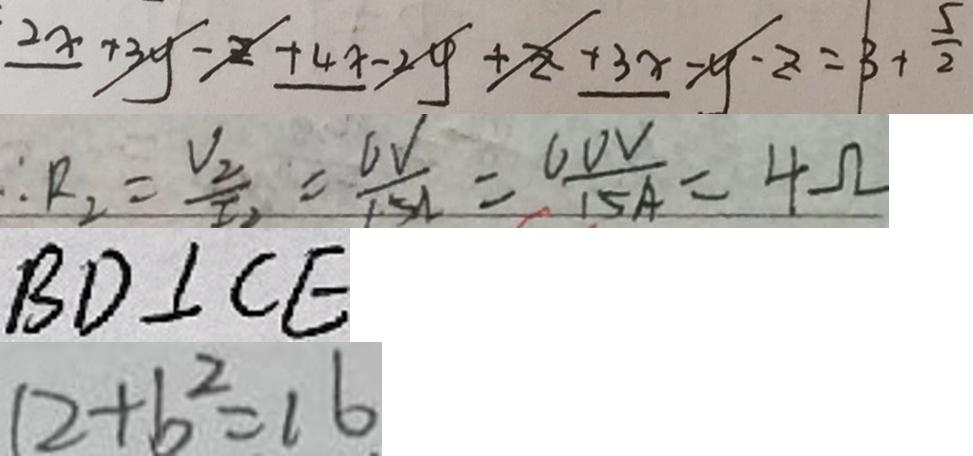<formula> <loc_0><loc_0><loc_500><loc_500>2 x + 3 y - z + 4 x - 2 y + z + 3 x - y - z = 3 + \frac { 5 } { 2 } 
 \therefore R _ { 2 } = \frac { V _ { 2 } } { I _ { 2 } } = \frac { 6 V } { 1 5 A } = \frac { 6 0 V } { 1 5 A } = 4 \Omega 
 B D \bot C E 
 1 2 + b ^ { 2 } = 1 6</formula> 